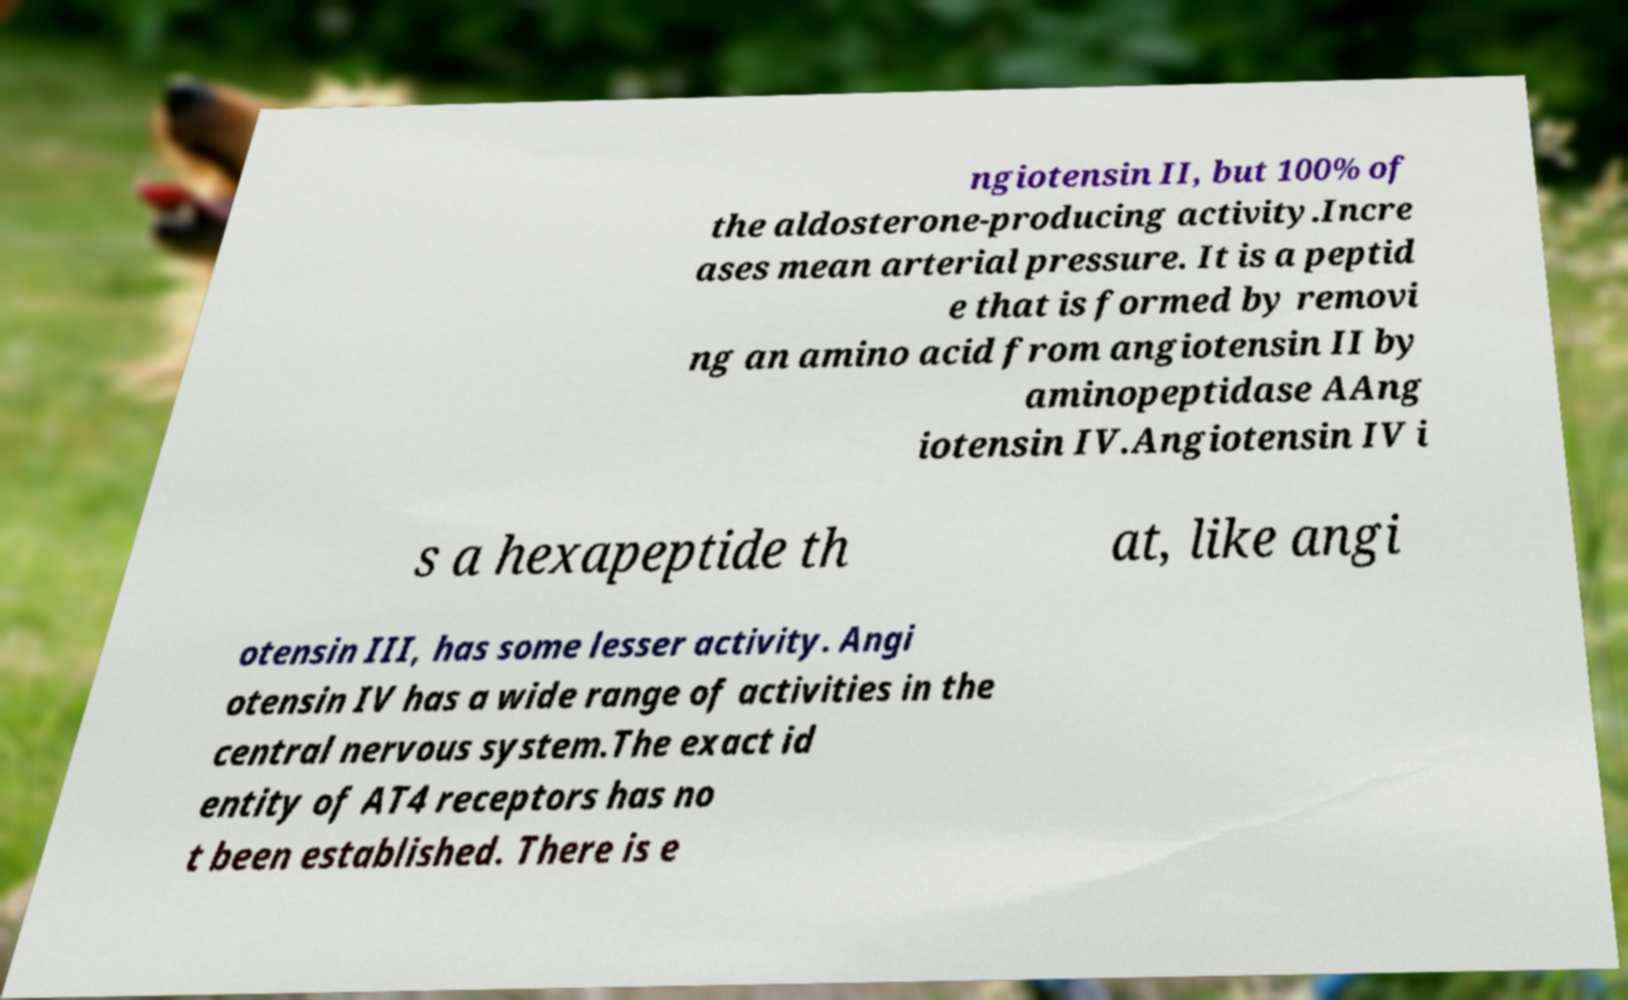I need the written content from this picture converted into text. Can you do that? ngiotensin II, but 100% of the aldosterone-producing activity.Incre ases mean arterial pressure. It is a peptid e that is formed by removi ng an amino acid from angiotensin II by aminopeptidase AAng iotensin IV.Angiotensin IV i s a hexapeptide th at, like angi otensin III, has some lesser activity. Angi otensin IV has a wide range of activities in the central nervous system.The exact id entity of AT4 receptors has no t been established. There is e 